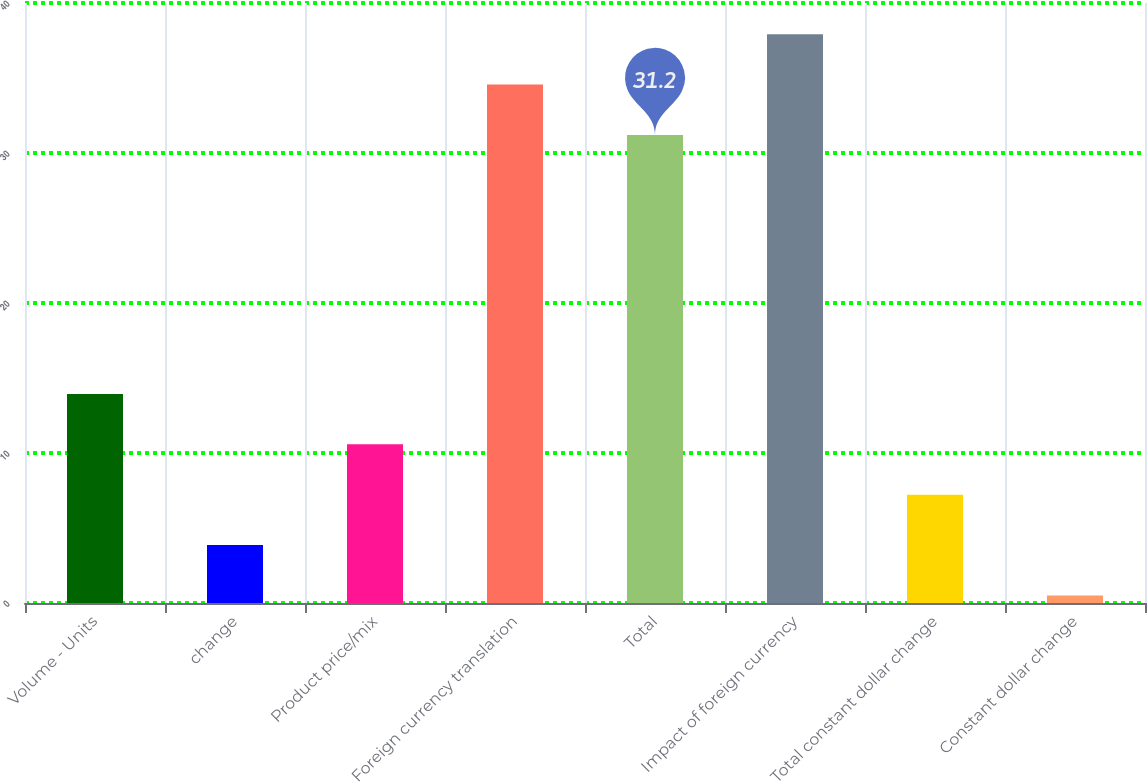Convert chart to OTSL. <chart><loc_0><loc_0><loc_500><loc_500><bar_chart><fcel>Volume - Units<fcel>change<fcel>Product price/mix<fcel>Foreign currency translation<fcel>Total<fcel>Impact of foreign currency<fcel>Total constant dollar change<fcel>Constant dollar change<nl><fcel>13.94<fcel>3.86<fcel>10.58<fcel>34.56<fcel>31.2<fcel>37.92<fcel>7.22<fcel>0.5<nl></chart> 